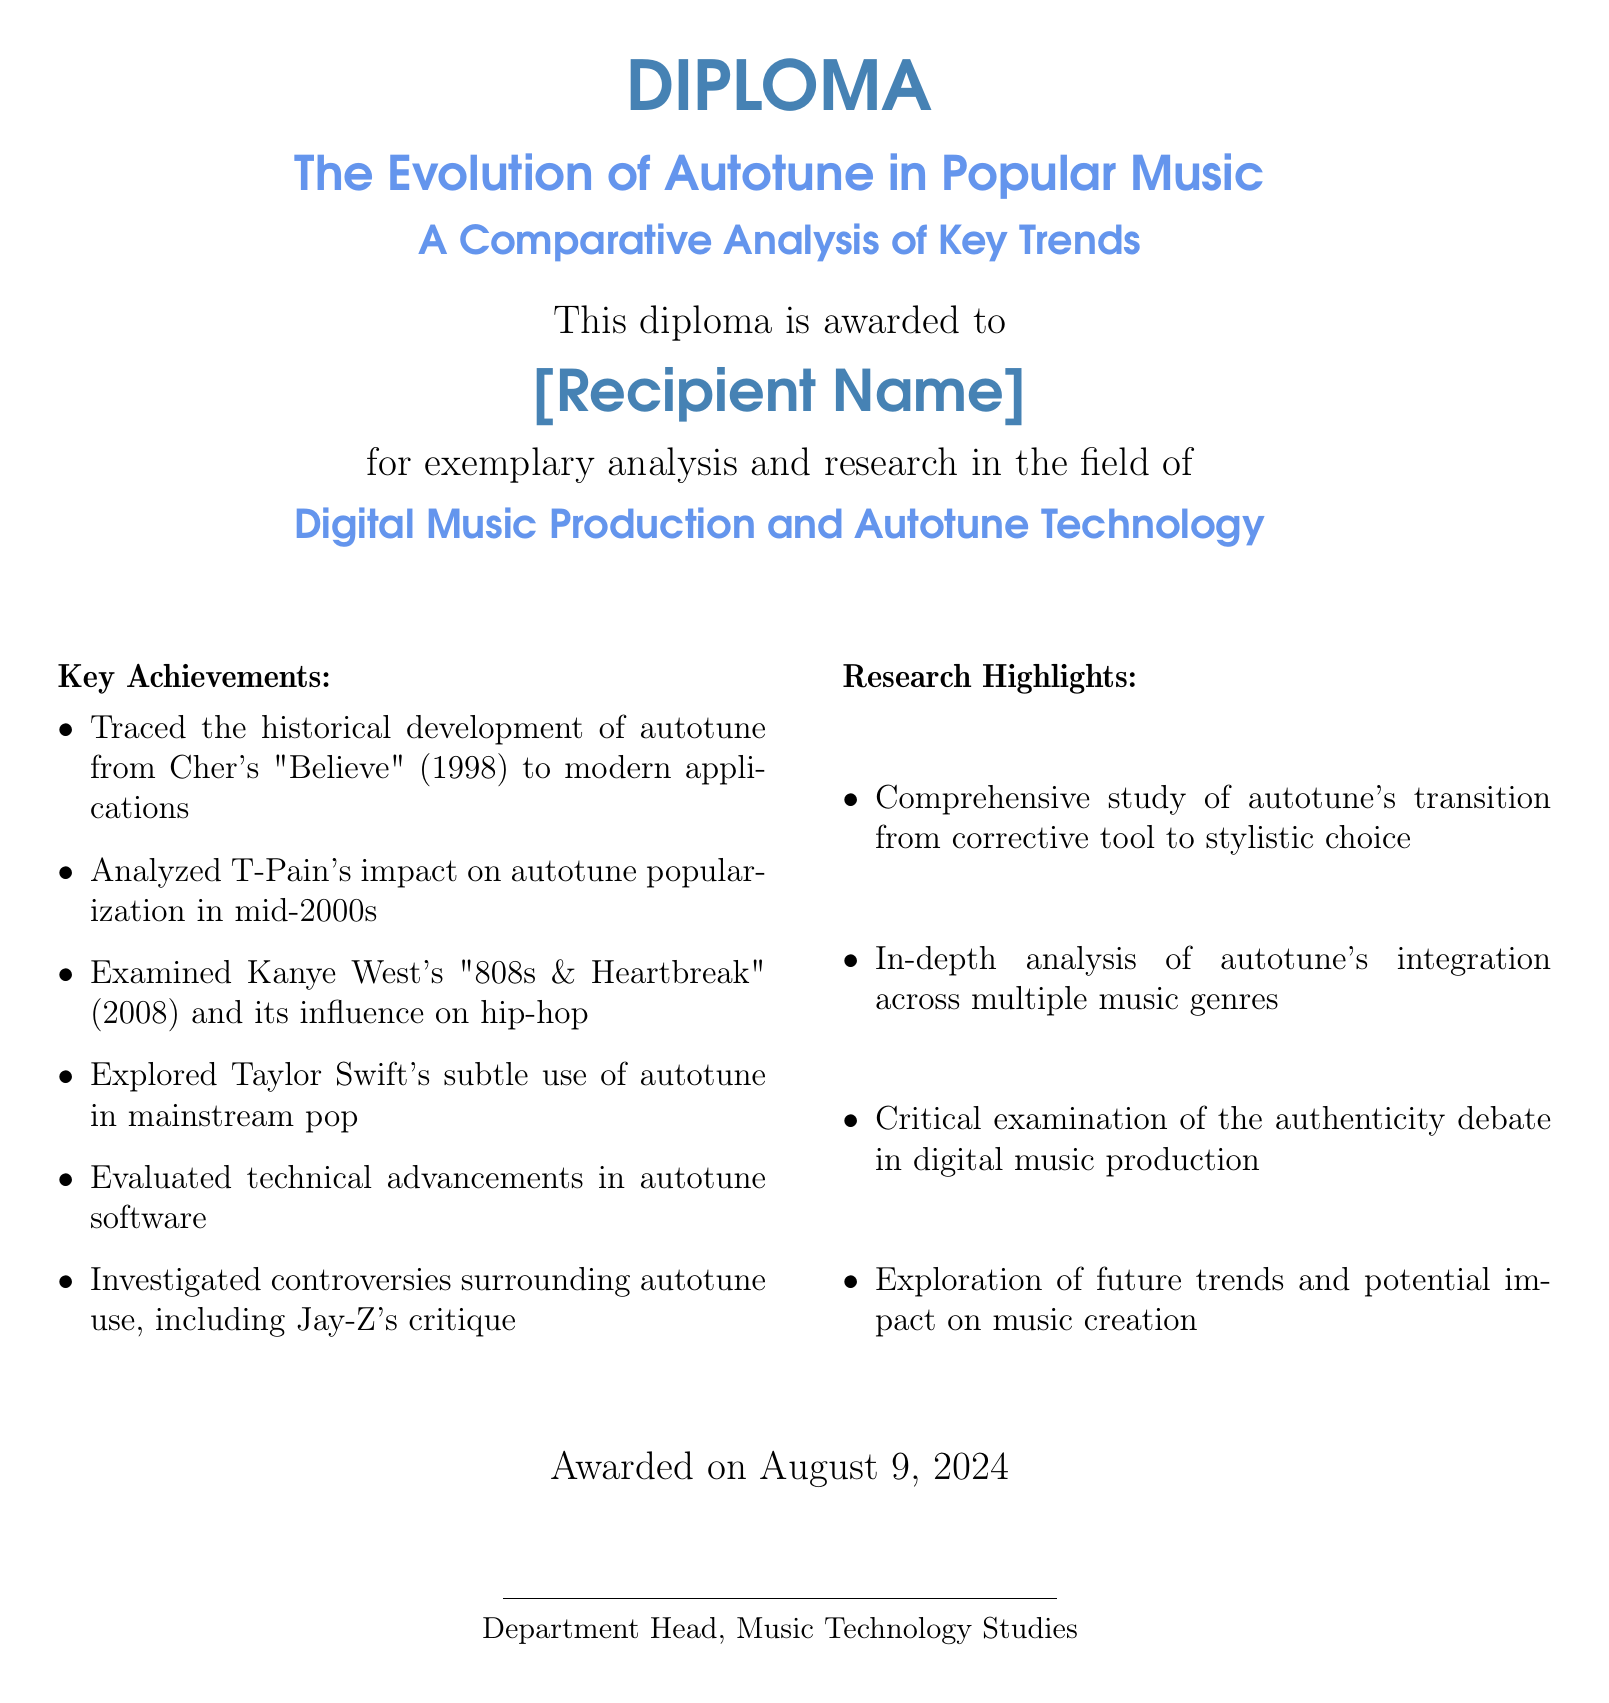what is the title of the diploma? The title is prominently displayed at the top of the document and reads "The Evolution of Autotune in Popular Music."
Answer: The Evolution of Autotune in Popular Music who is the recipient of the diploma? The document specifies "[Recipient Name]" as a placeholder for the individual who receives the diploma.
Answer: [Recipient Name] what year did Cher's "Believe" release, marking the historical development of autotune? The document states the year of release as 1998.
Answer: 1998 which artist popularized autotune in the mid-2000s? The document highlights T-Pain's significant role in popularizing autotune during that time.
Answer: T-Pain what album by Kanye West is mentioned in the document? The document refers to "808s & Heartbreak" as a key album in the analysis.
Answer: 808s & Heartbreak how does the document describe autotune's role in music production? The document indicates autotune has transitioned from a corrective tool to a stylistic choice.
Answer: Stylistic choice what is one of the controversies surrounding autotune described in the document? The document mentions Jay-Z's critique regarding autotune as a significant controversy.
Answer: Jay-Z's critique when was the diploma awarded? The document indicates the diploma was awarded on the date shown as today.
Answer: today who signed the diploma? The signatory is described as the "Department Head, Music Technology Studies."
Answer: Department Head, Music Technology Studies 